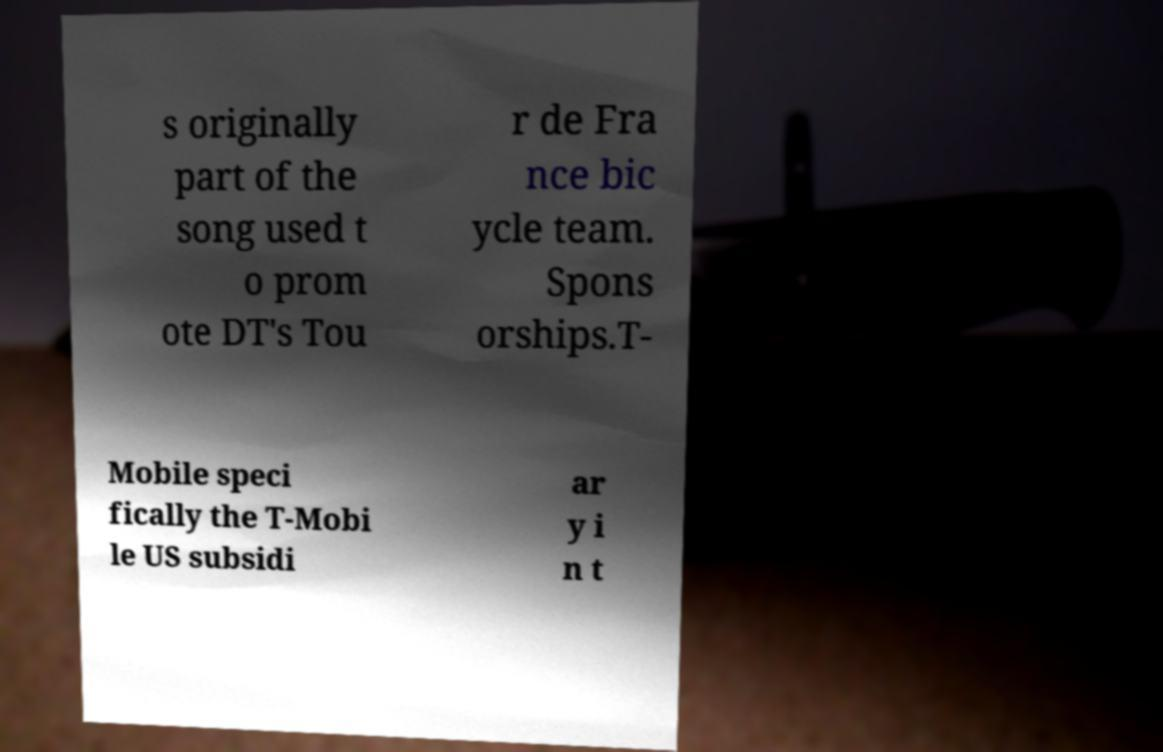Could you extract and type out the text from this image? s originally part of the song used t o prom ote DT's Tou r de Fra nce bic ycle team. Spons orships.T- Mobile speci fically the T-Mobi le US subsidi ar y i n t 